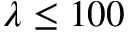Convert formula to latex. <formula><loc_0><loc_0><loc_500><loc_500>\lambda \leq 1 0 0</formula> 